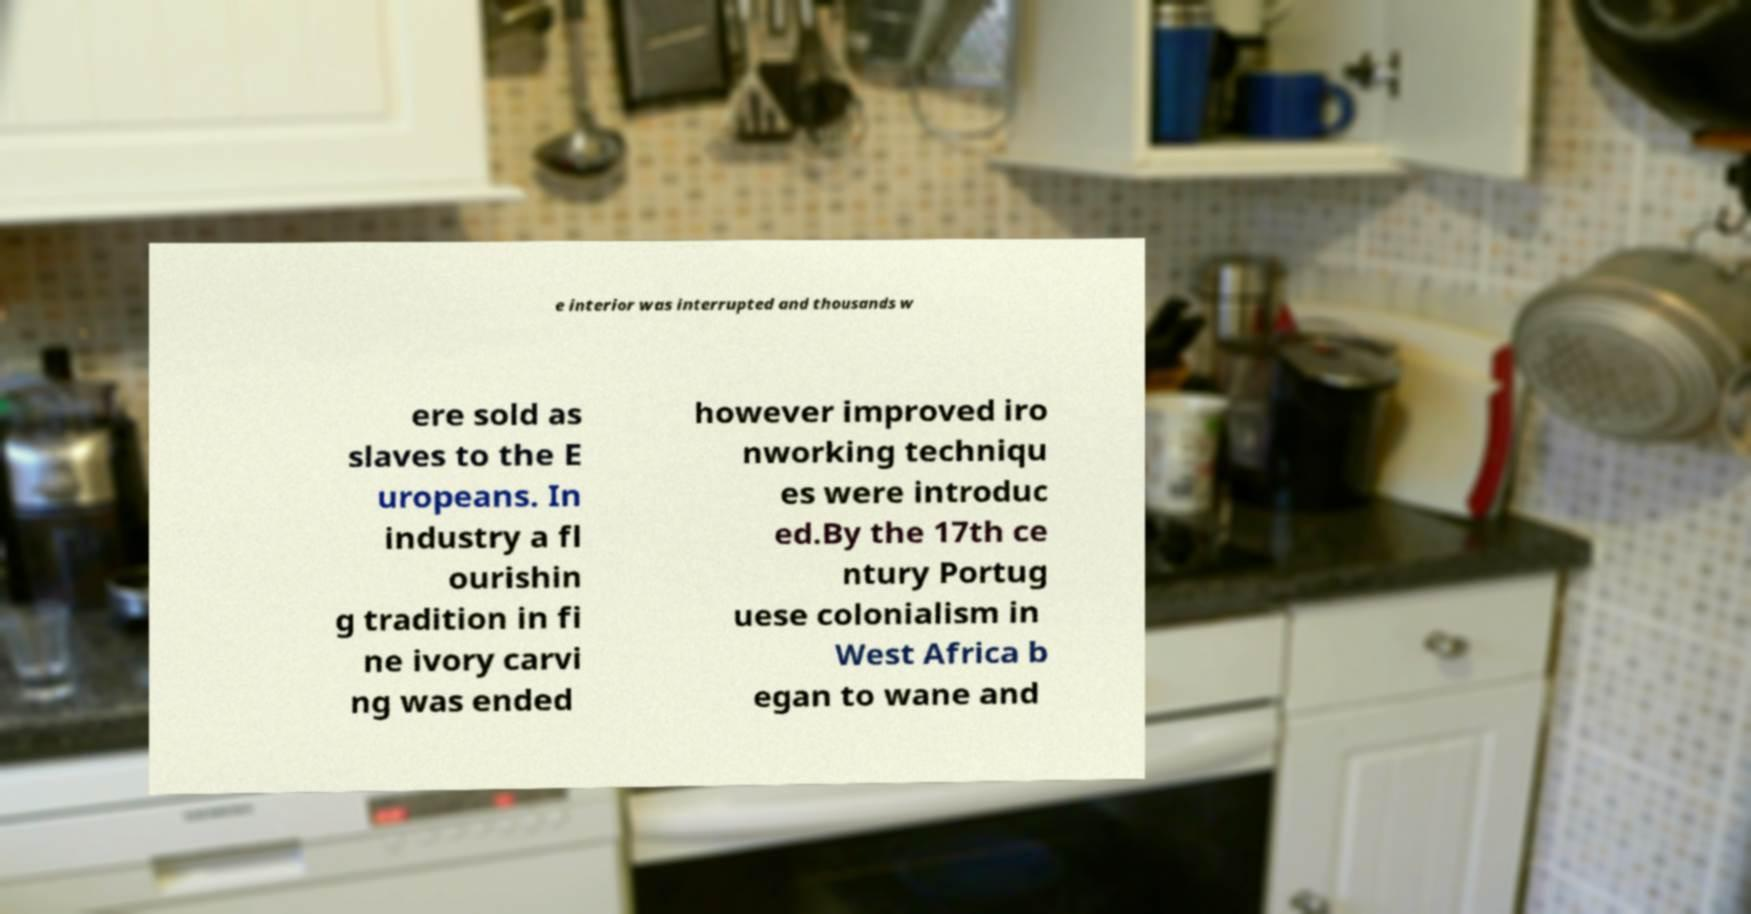I need the written content from this picture converted into text. Can you do that? e interior was interrupted and thousands w ere sold as slaves to the E uropeans. In industry a fl ourishin g tradition in fi ne ivory carvi ng was ended however improved iro nworking techniqu es were introduc ed.By the 17th ce ntury Portug uese colonialism in West Africa b egan to wane and 